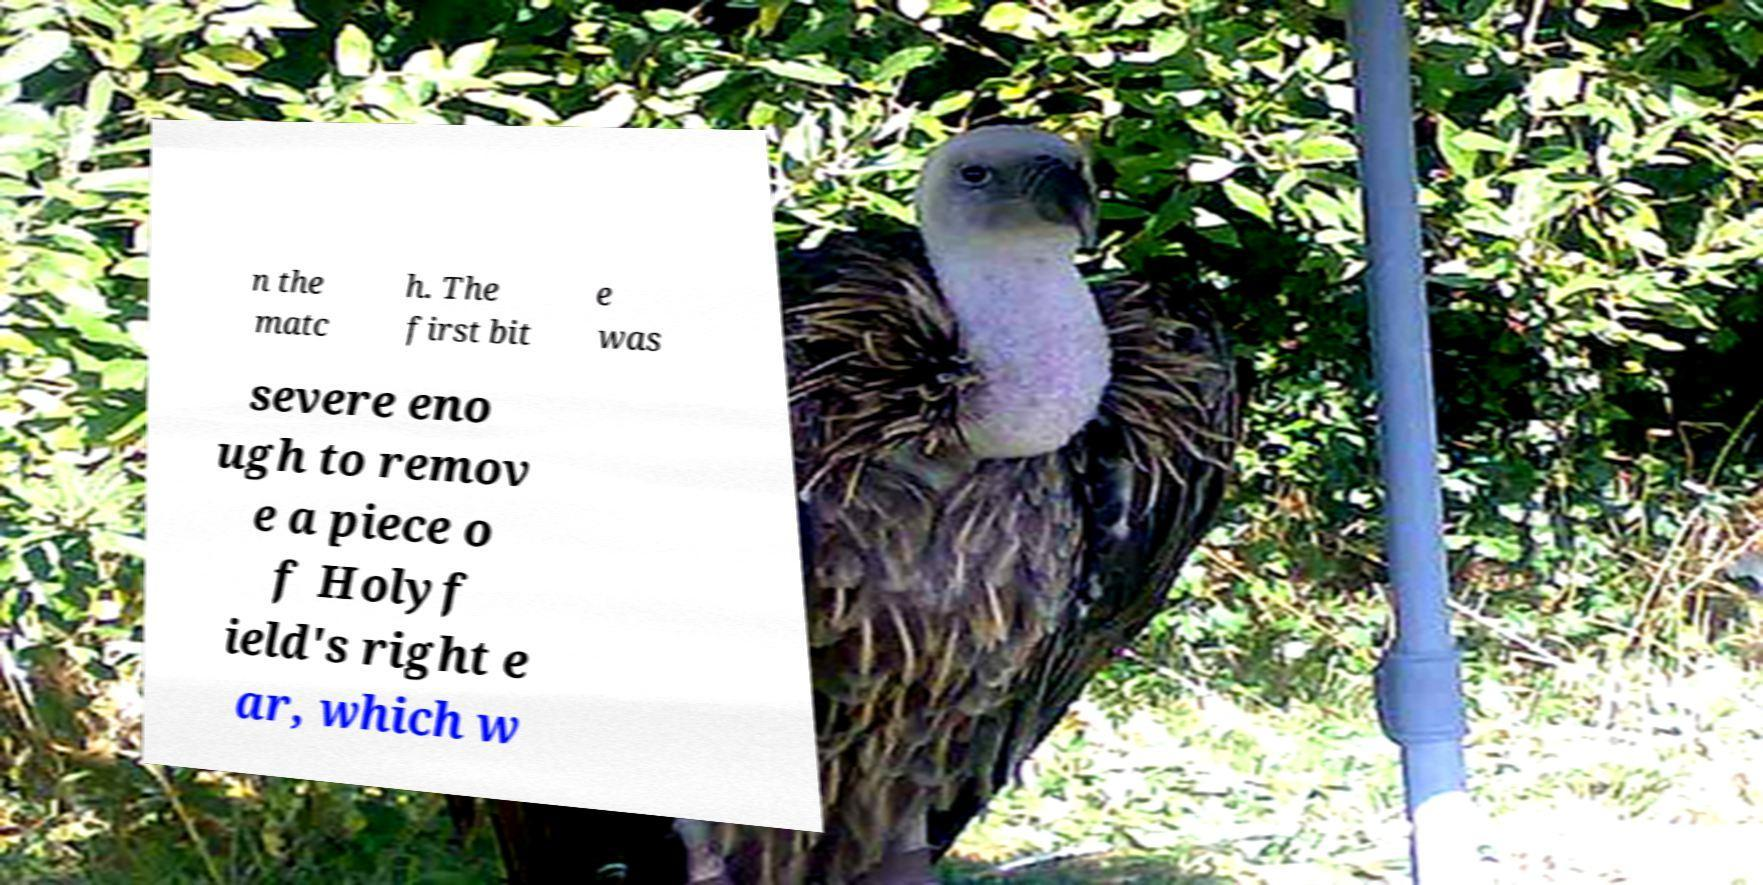There's text embedded in this image that I need extracted. Can you transcribe it verbatim? n the matc h. The first bit e was severe eno ugh to remov e a piece o f Holyf ield's right e ar, which w 